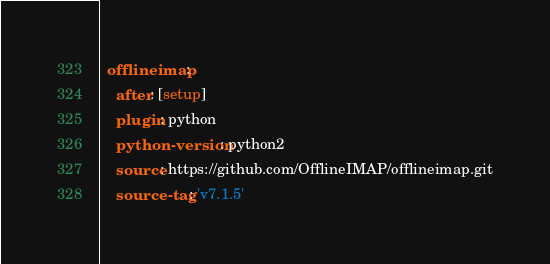<code> <loc_0><loc_0><loc_500><loc_500><_YAML_>  offlineimap:
    after: [setup]
    plugin: python
    python-version: python2
    source: https://github.com/OfflineIMAP/offlineimap.git
    source-tag: 'v7.1.5'
</code> 